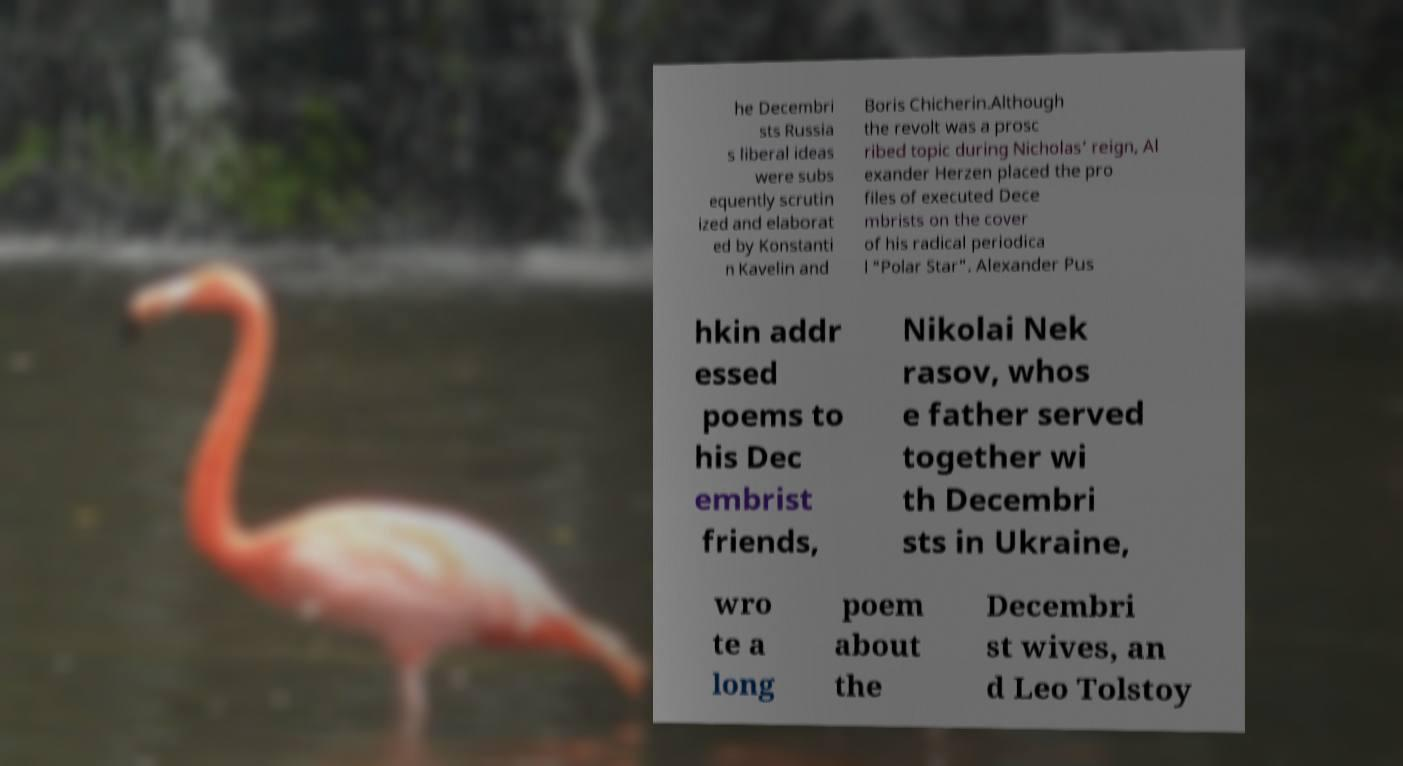What messages or text are displayed in this image? I need them in a readable, typed format. he Decembri sts Russia s liberal ideas were subs equently scrutin ized and elaborat ed by Konstanti n Kavelin and Boris Chicherin.Although the revolt was a prosc ribed topic during Nicholas’ reign, Al exander Herzen placed the pro files of executed Dece mbrists on the cover of his radical periodica l "Polar Star". Alexander Pus hkin addr essed poems to his Dec embrist friends, Nikolai Nek rasov, whos e father served together wi th Decembri sts in Ukraine, wro te a long poem about the Decembri st wives, an d Leo Tolstoy 